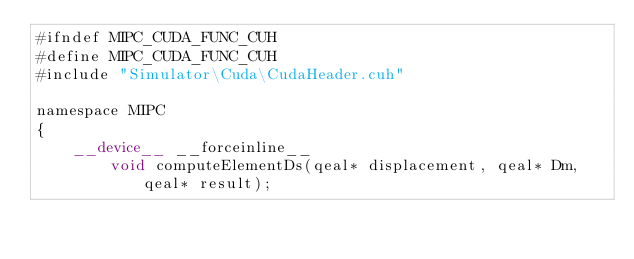<code> <loc_0><loc_0><loc_500><loc_500><_Cuda_>#ifndef MIPC_CUDA_FUNC_CUH
#define MIPC_CUDA_FUNC_CUH
#include "Simulator\Cuda\CudaHeader.cuh"

namespace MIPC
{	
	__device__ __forceinline__
		void computeElementDs(qeal* displacement, qeal* Dm, qeal* result);
	</code> 